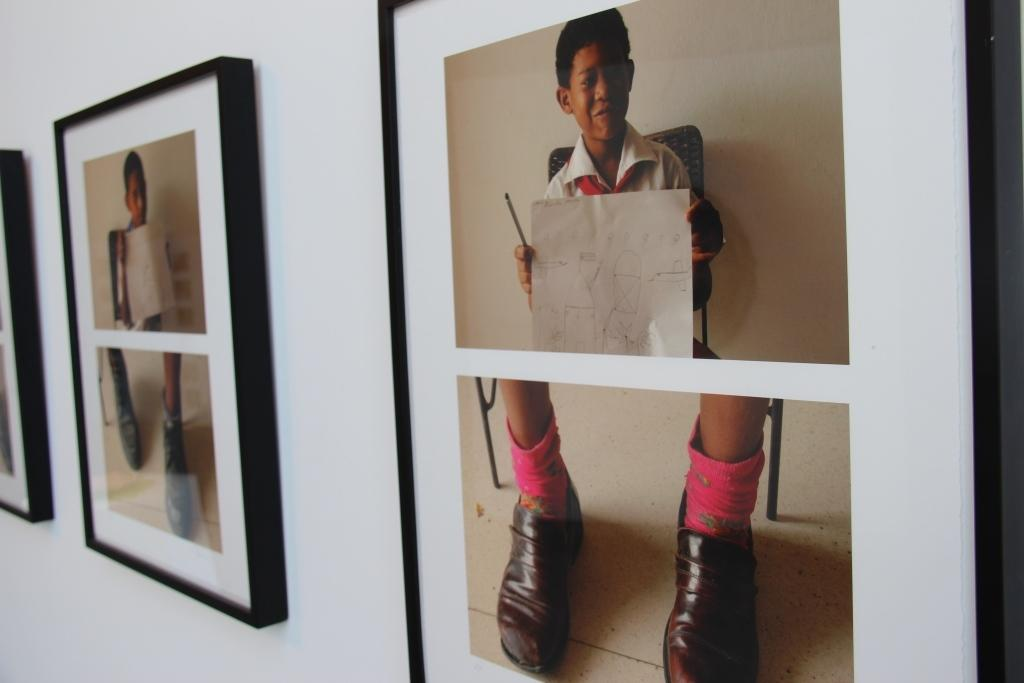What is the color of the wall in the image? The wall in the image is white. How many photo frames are on the wall? There are 3 photo frames on the wall. What can be seen in the photo frames? The photo frames contain pictures of children. What are the children doing in the pictures? The children are sitting on chairs and holding a paper in the pictures. What type of insurance policy is being discussed in the image? There is no mention of insurance in the image; it features a white wall with photo frames containing pictures of children. Can you hear the sound of thunder in the image? There is no sound in the image, and therefore no thunder can be heard. 